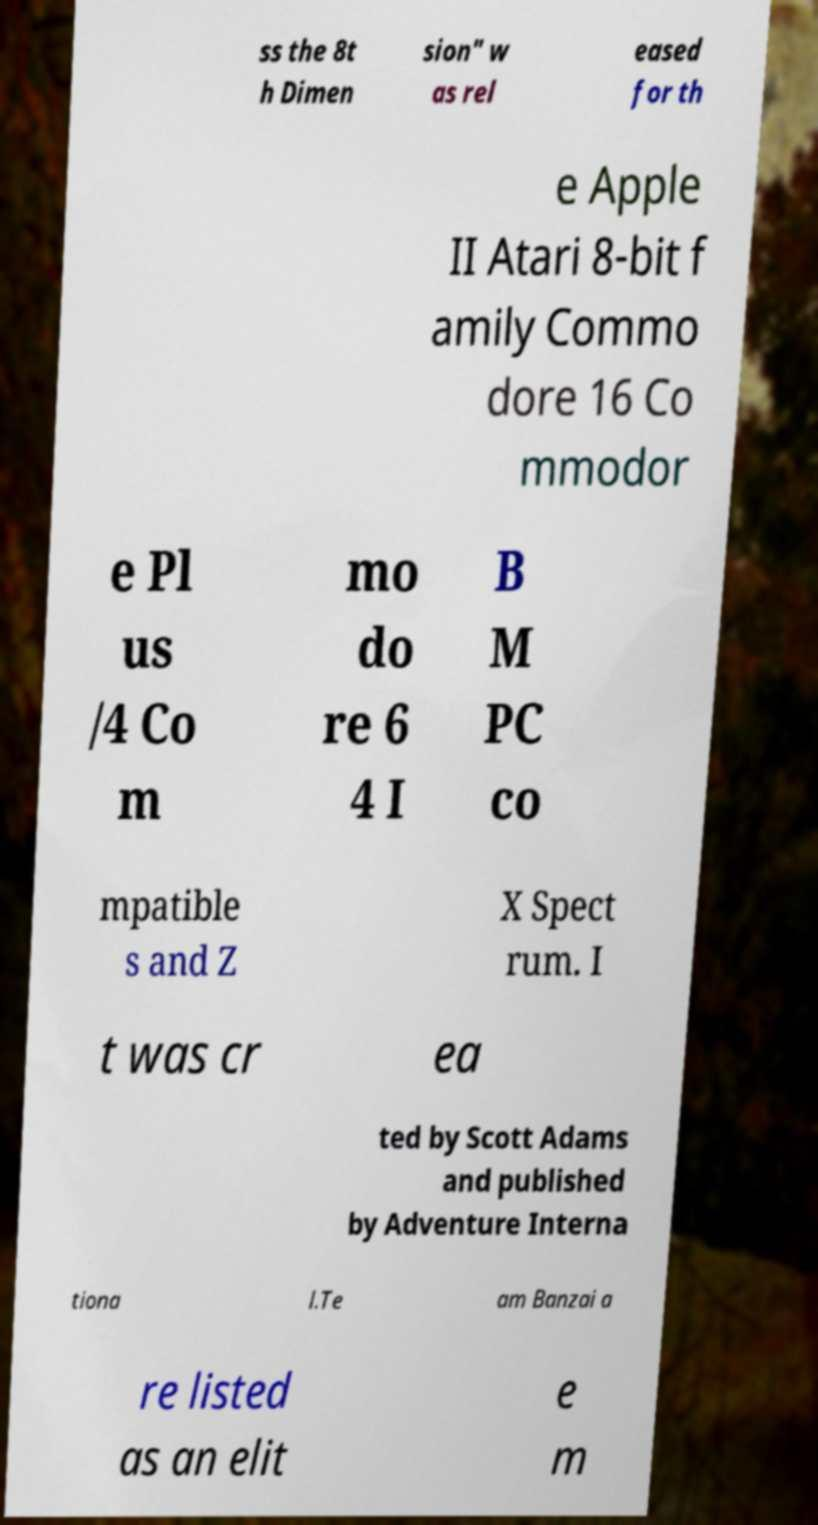There's text embedded in this image that I need extracted. Can you transcribe it verbatim? ss the 8t h Dimen sion" w as rel eased for th e Apple II Atari 8-bit f amily Commo dore 16 Co mmodor e Pl us /4 Co m mo do re 6 4 I B M PC co mpatible s and Z X Spect rum. I t was cr ea ted by Scott Adams and published by Adventure Interna tiona l.Te am Banzai a re listed as an elit e m 